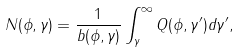Convert formula to latex. <formula><loc_0><loc_0><loc_500><loc_500>N ( \phi , \gamma ) = \frac { 1 } { b ( \phi , \gamma ) } \int _ { \gamma } ^ { \infty } Q ( \phi , \gamma ^ { \prime } ) d \gamma ^ { \prime } ,</formula> 